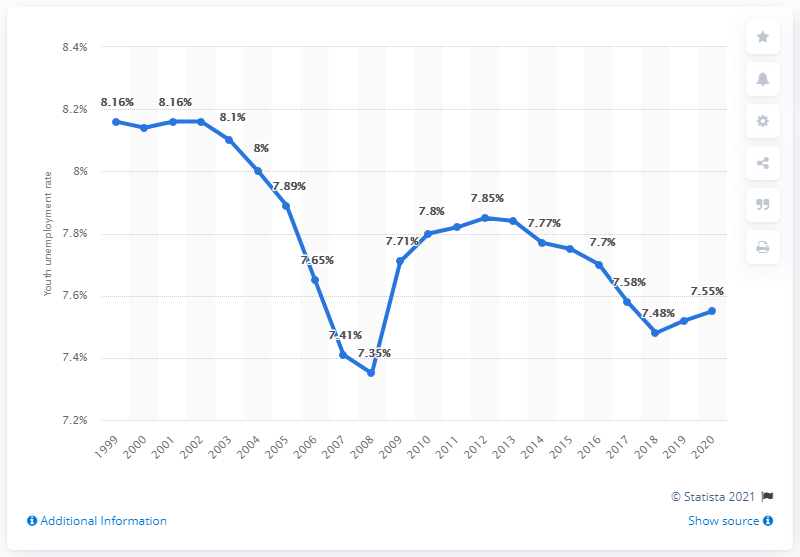Give some essential details in this illustration. In 2020, the youth unemployment rate in Malawi was 7.55%. 